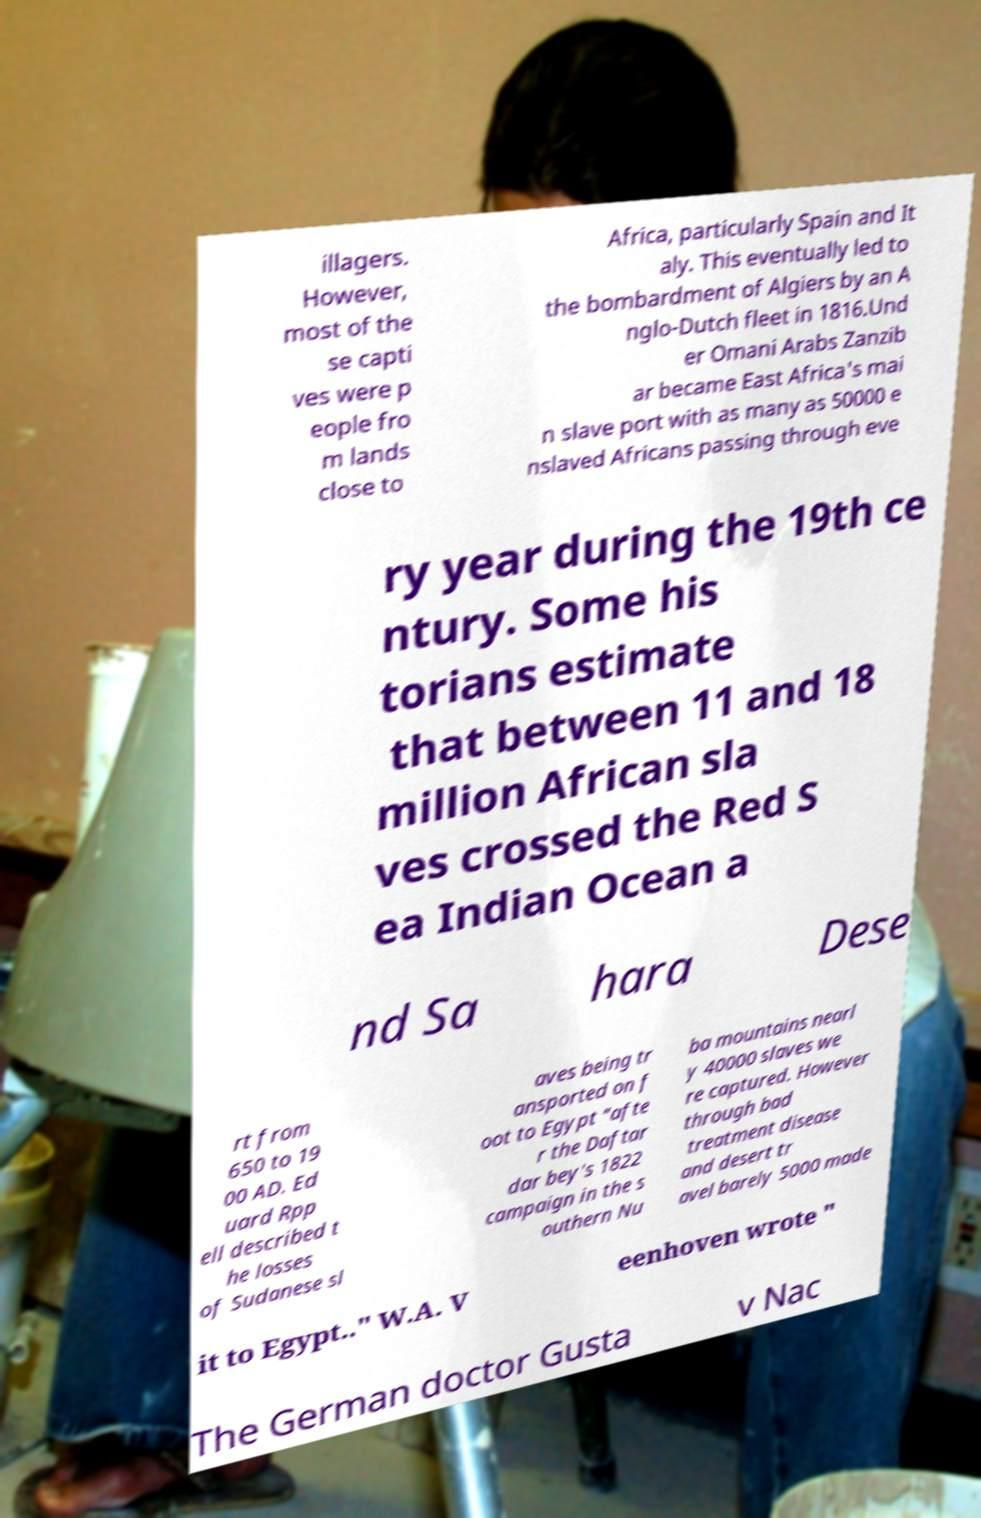Can you accurately transcribe the text from the provided image for me? illagers. However, most of the se capti ves were p eople fro m lands close to Africa, particularly Spain and It aly. This eventually led to the bombardment of Algiers by an A nglo-Dutch fleet in 1816.Und er Omani Arabs Zanzib ar became East Africa's mai n slave port with as many as 50000 e nslaved Africans passing through eve ry year during the 19th ce ntury. Some his torians estimate that between 11 and 18 million African sla ves crossed the Red S ea Indian Ocean a nd Sa hara Dese rt from 650 to 19 00 AD. Ed uard Rpp ell described t he losses of Sudanese sl aves being tr ansported on f oot to Egypt "afte r the Daftar dar bey's 1822 campaign in the s outhern Nu ba mountains nearl y 40000 slaves we re captured. However through bad treatment disease and desert tr avel barely 5000 made it to Egypt.." W.A. V eenhoven wrote " The German doctor Gusta v Nac 